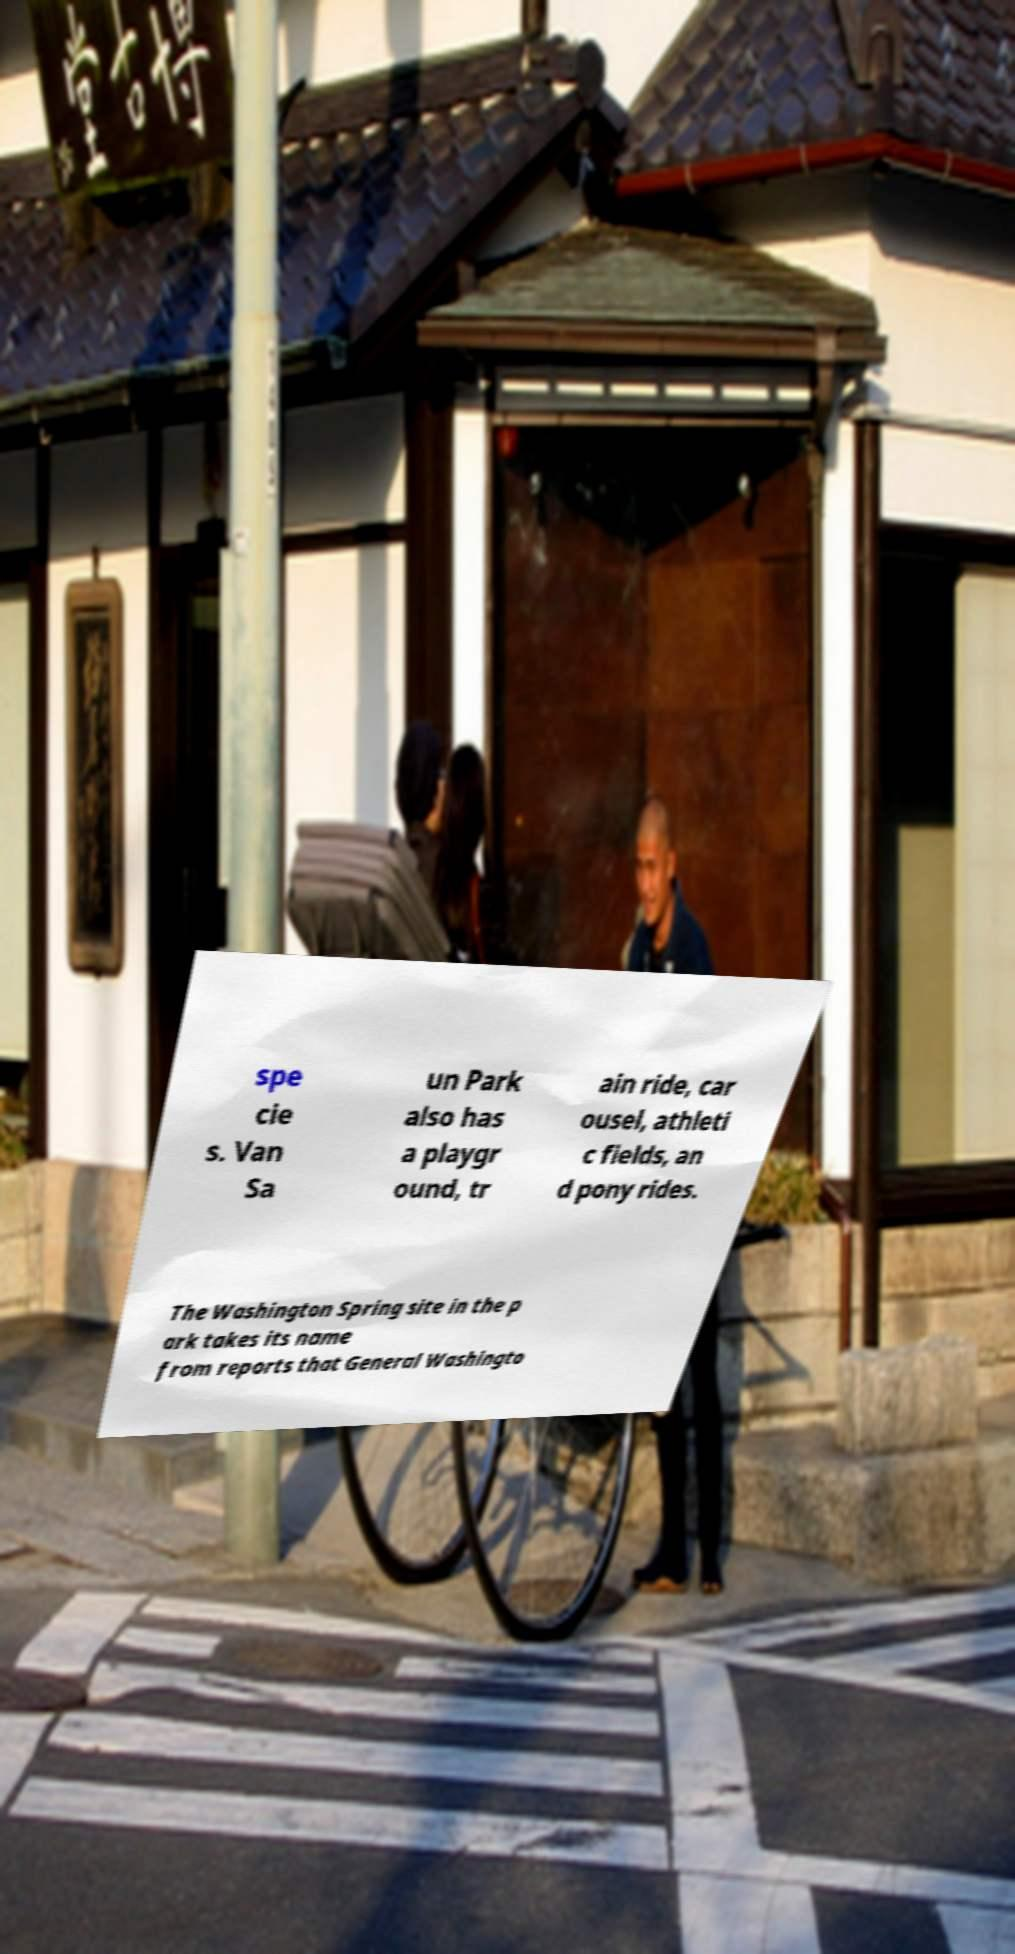Can you accurately transcribe the text from the provided image for me? spe cie s. Van Sa un Park also has a playgr ound, tr ain ride, car ousel, athleti c fields, an d pony rides. The Washington Spring site in the p ark takes its name from reports that General Washingto 